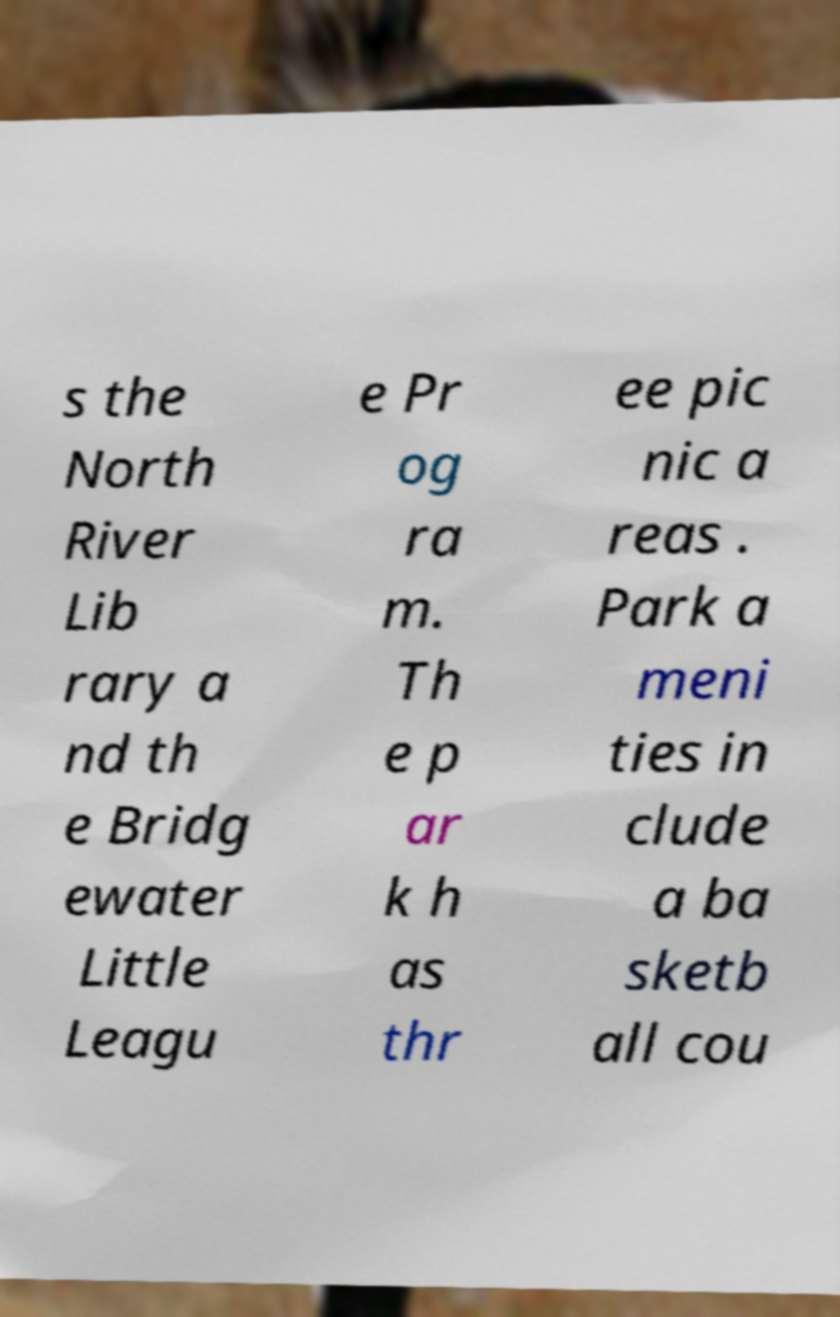What messages or text are displayed in this image? I need them in a readable, typed format. s the North River Lib rary a nd th e Bridg ewater Little Leagu e Pr og ra m. Th e p ar k h as thr ee pic nic a reas . Park a meni ties in clude a ba sketb all cou 